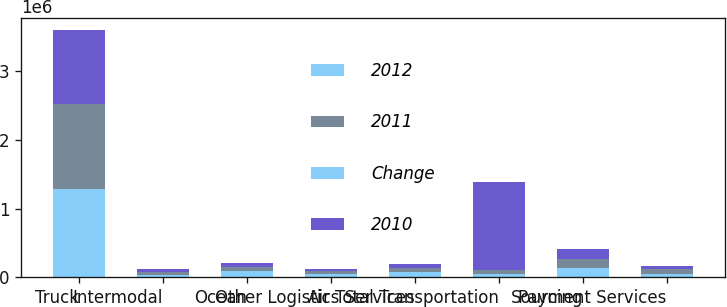<chart> <loc_0><loc_0><loc_500><loc_500><stacked_bar_chart><ecel><fcel>Truck<fcel>Intermodal<fcel>Ocean<fcel>Air<fcel>Other Logistics Services<fcel>Total Transportation<fcel>Sourcing<fcel>Payment Services<nl><fcel>2012<fcel>1.28428e+06<fcel>38815<fcel>84924<fcel>44444<fcel>75674<fcel>54234<fcel>136438<fcel>52996<nl><fcel>2011<fcel>1.23661e+06<fcel>41189<fcel>66873<fcel>39371<fcel>59872<fcel>54234<fcel>128448<fcel>60294<nl><fcel>Change<fcel>3.9<fcel>5.8<fcel>27<fcel>12.9<fcel>26.4<fcel>5.8<fcel>6.2<fcel>12.1<nl><fcel>2010<fcel>1.07625e+06<fcel>36550<fcel>60763<fcel>42315<fcel>57254<fcel>1.27313e+06<fcel>139377<fcel>55472<nl></chart> 